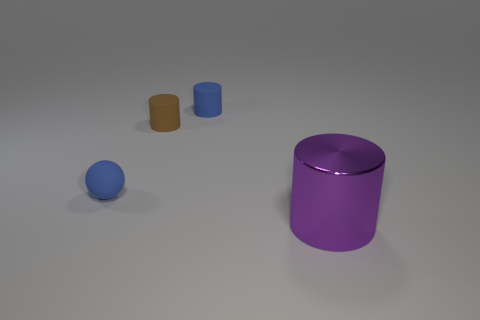Subtract all matte cylinders. How many cylinders are left? 1 Add 3 large purple shiny objects. How many objects exist? 7 Subtract all balls. How many objects are left? 3 Add 2 small brown objects. How many small brown objects are left? 3 Add 2 big purple cylinders. How many big purple cylinders exist? 3 Subtract 0 red cylinders. How many objects are left? 4 Subtract all tiny objects. Subtract all purple metallic objects. How many objects are left? 0 